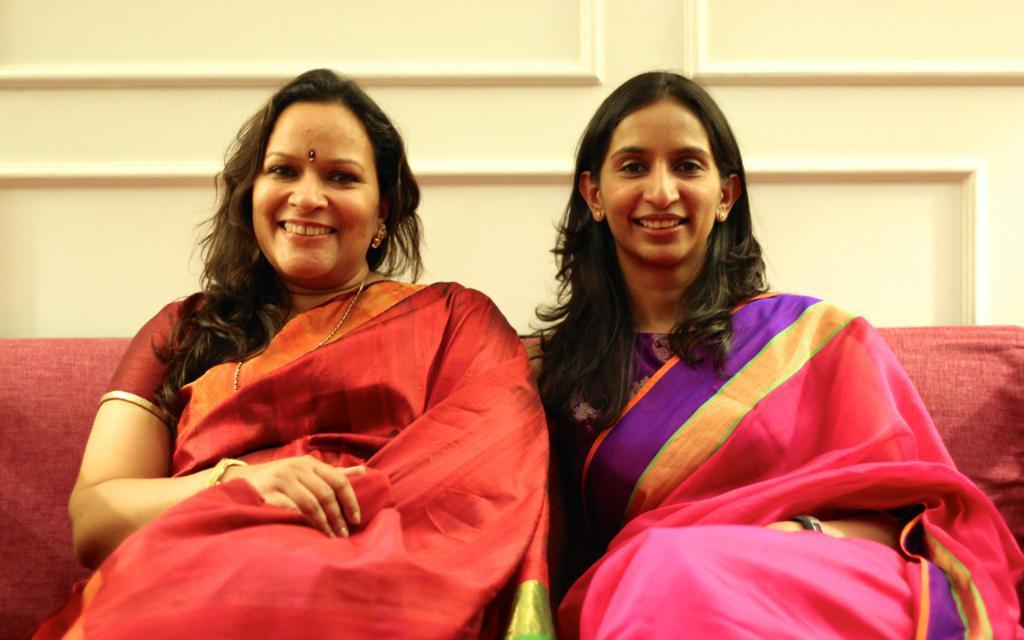Could you give a brief overview of what you see in this image? There are two ladies wearing saree and sitting sofa. In the background there is a wall. 